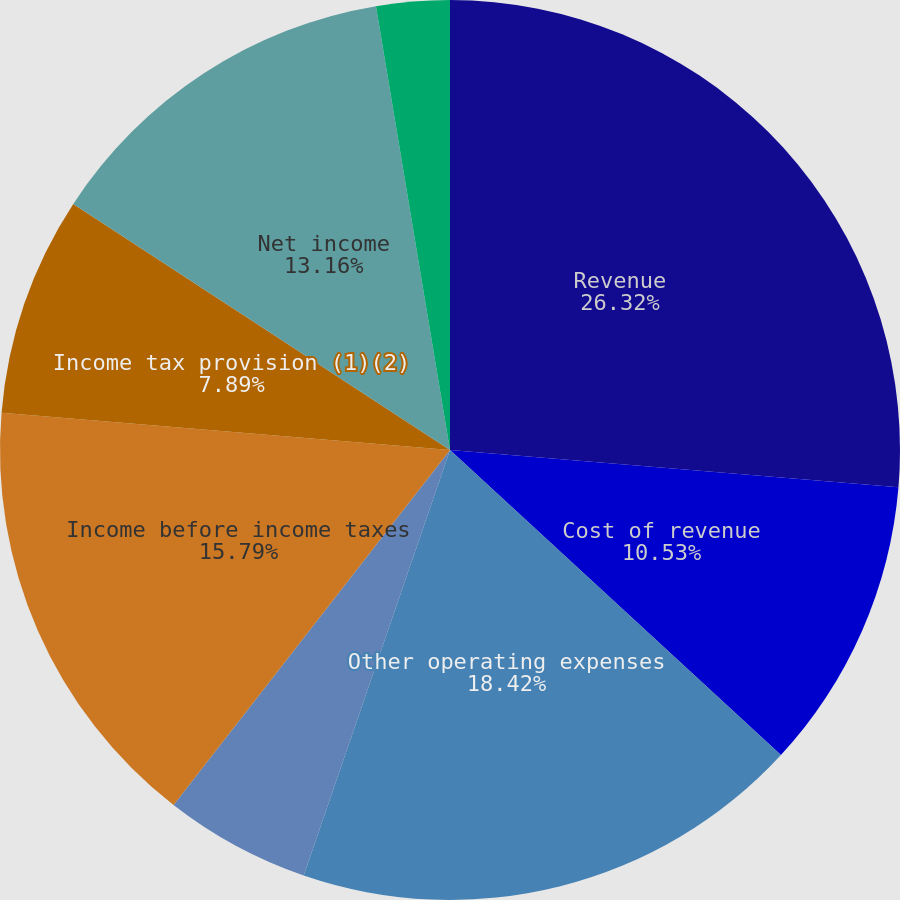Convert chart. <chart><loc_0><loc_0><loc_500><loc_500><pie_chart><fcel>Revenue<fcel>Cost of revenue<fcel>Other operating expenses<fcel>Other income net<fcel>Income before income taxes<fcel>Income tax provision (1)(2)<fcel>Net income<fcel>Basic net income per share<fcel>Diluted net income per share<nl><fcel>26.32%<fcel>10.53%<fcel>18.42%<fcel>5.26%<fcel>15.79%<fcel>7.89%<fcel>13.16%<fcel>2.63%<fcel>0.0%<nl></chart> 